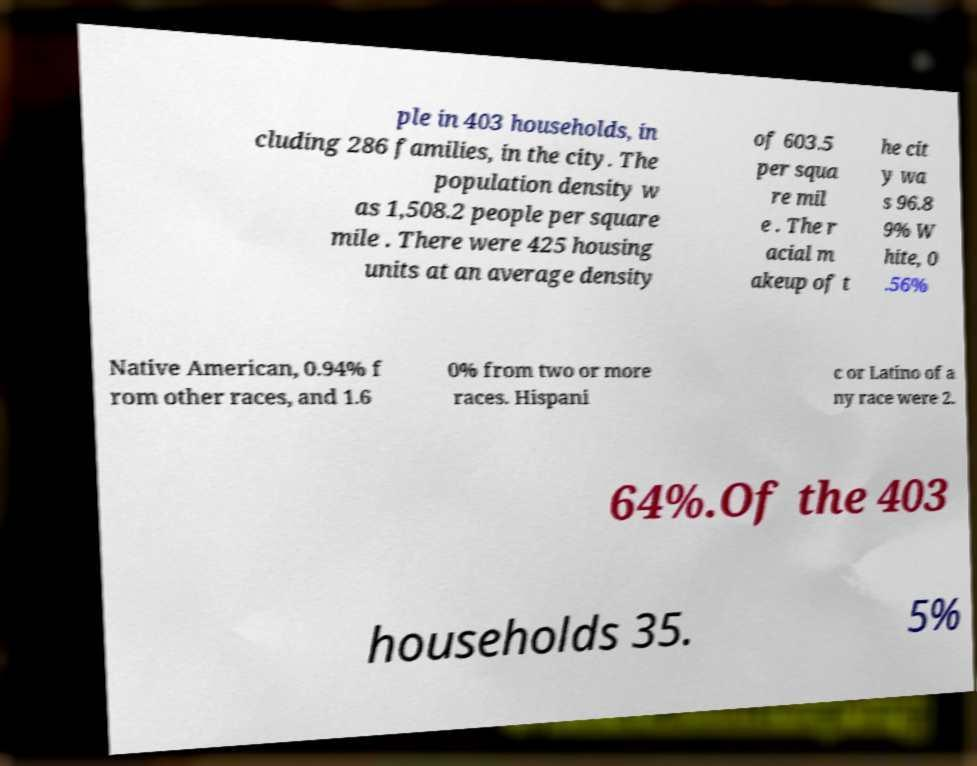Please read and relay the text visible in this image. What does it say? ple in 403 households, in cluding 286 families, in the city. The population density w as 1,508.2 people per square mile . There were 425 housing units at an average density of 603.5 per squa re mil e . The r acial m akeup of t he cit y wa s 96.8 9% W hite, 0 .56% Native American, 0.94% f rom other races, and 1.6 0% from two or more races. Hispani c or Latino of a ny race were 2. 64%.Of the 403 households 35. 5% 